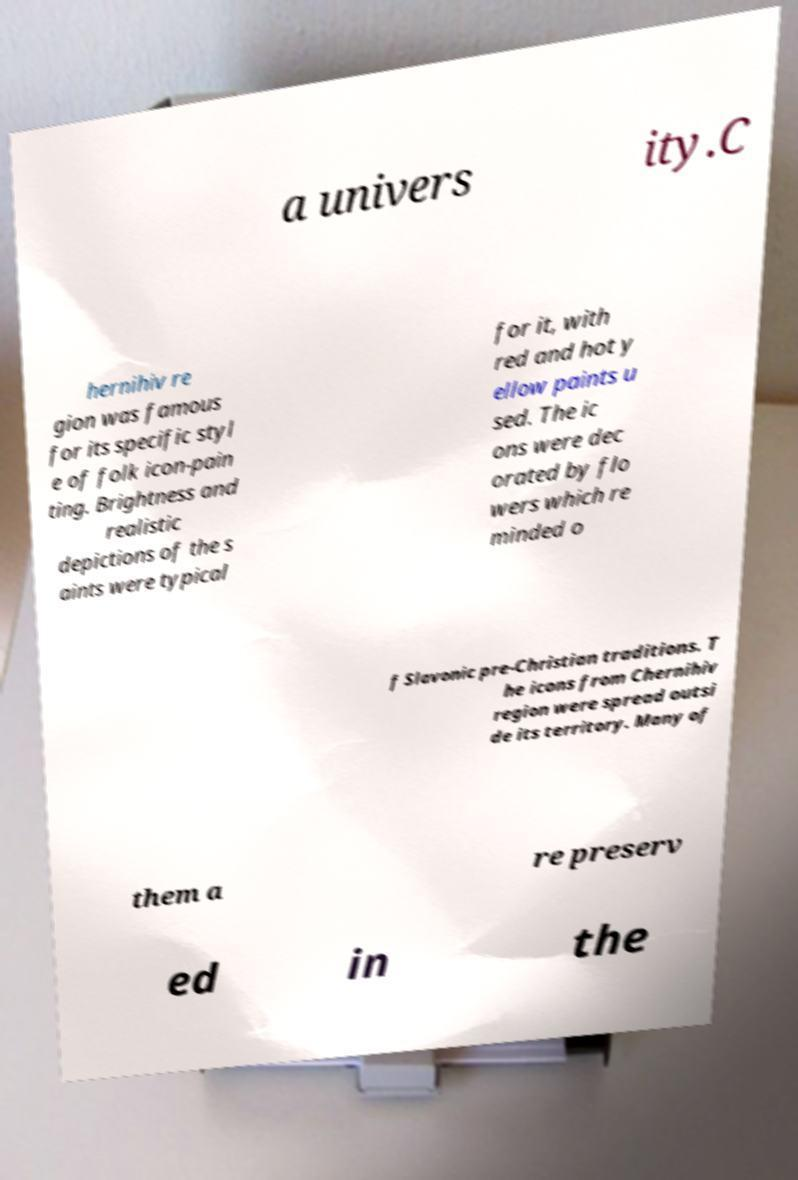Please identify and transcribe the text found in this image. a univers ity.C hernihiv re gion was famous for its specific styl e of folk icon-pain ting. Brightness and realistic depictions of the s aints were typical for it, with red and hot y ellow paints u sed. The ic ons were dec orated by flo wers which re minded o f Slavonic pre-Christian traditions. T he icons from Chernihiv region were spread outsi de its territory. Many of them a re preserv ed in the 